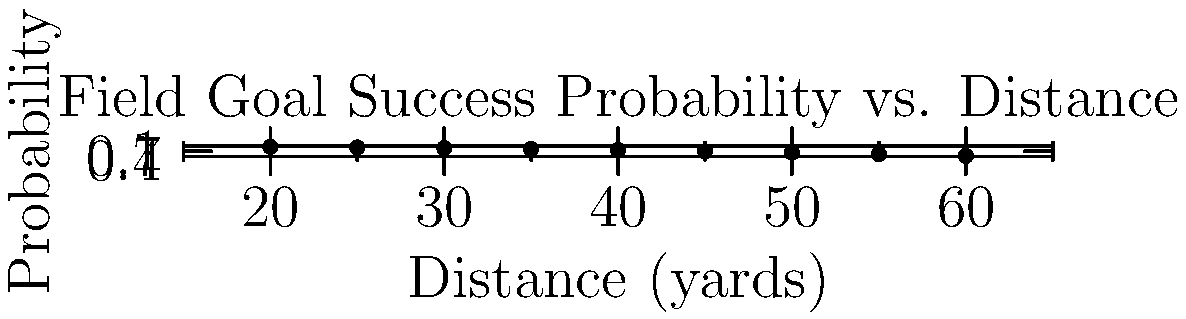Based on the scatter plot showing field goal success probability versus distance, estimate the probability of successfully making a 42-yard field goal. How does this compare to the probability of making a 28-yard field goal, and what does this imply about field goal strategy? To answer this question, we need to analyze the scatter plot and interpolate the probabilities for the given distances. Let's break it down step-by-step:

1. For a 42-yard field goal:
   - This falls between the 40-yard (0.77 probability) and 45-yard (0.70 probability) data points.
   - Interpolating, we can estimate the probability to be approximately 0.75 or 75%.

2. For a 28-yard field goal:
   - This falls between the 25-yard (0.92 probability) and 30-yard (0.88 probability) data points.
   - Interpolating, we can estimate the probability to be approximately 0.90 or 90%.

3. Comparing the probabilities:
   - 42-yard field goal: ~75% success rate
   - 28-yard field goal: ~90% success rate
   - The difference is about 15 percentage points.

4. Implications for field goal strategy:
   - Shorter field goals (like 28 yards) have a significantly higher success rate.
   - The probability decreases notably as the distance increases.
   - Coaches and players must weigh the risk-reward of attempting longer field goals versus other options (e.g., going for it on fourth down or punting).
   - In critical game situations, the higher probability of success for shorter field goals might influence play-calling to get closer to the end zone before attempting a field goal.
Answer: 42-yard: ~75%, 28-yard: ~90%. Shorter kicks are significantly more reliable, influencing late-game strategy. 